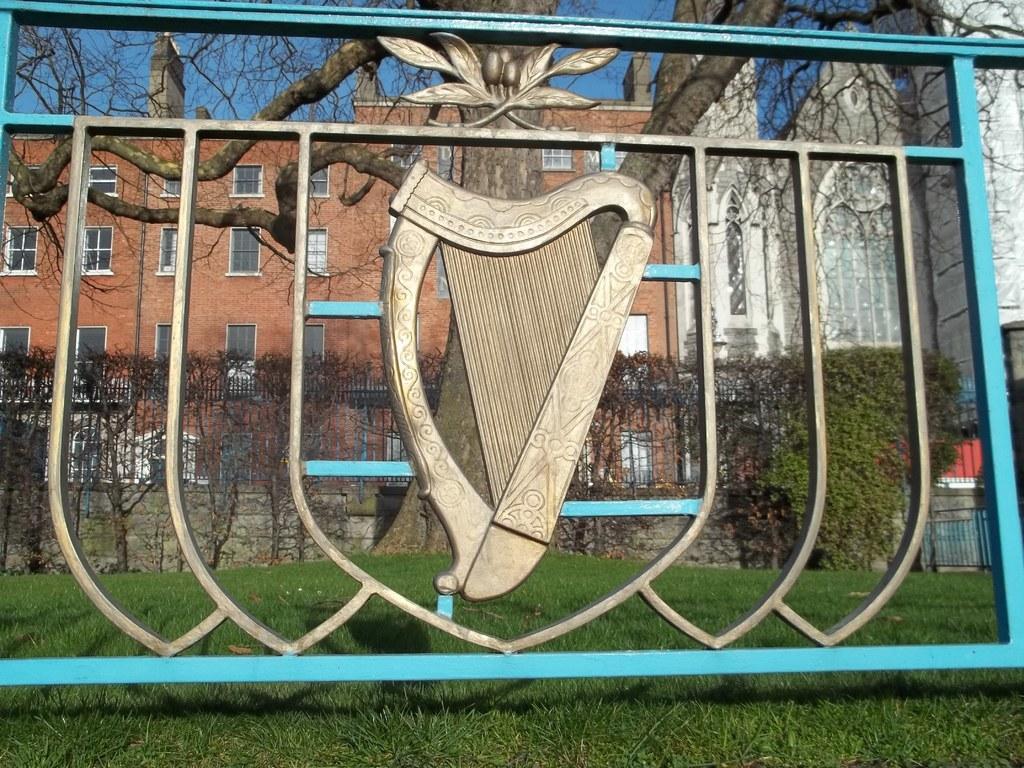How would you summarize this image in a sentence or two? In this picture we can see a fence, grass, trees, buildings with windows and in the background we can see the sky. 